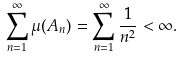Convert formula to latex. <formula><loc_0><loc_0><loc_500><loc_500>\sum _ { n = 1 } ^ { \infty } \mu ( A _ { n } ) = \sum _ { n = 1 } ^ { \infty } \frac { 1 } { n ^ { 2 } } < \infty .</formula> 